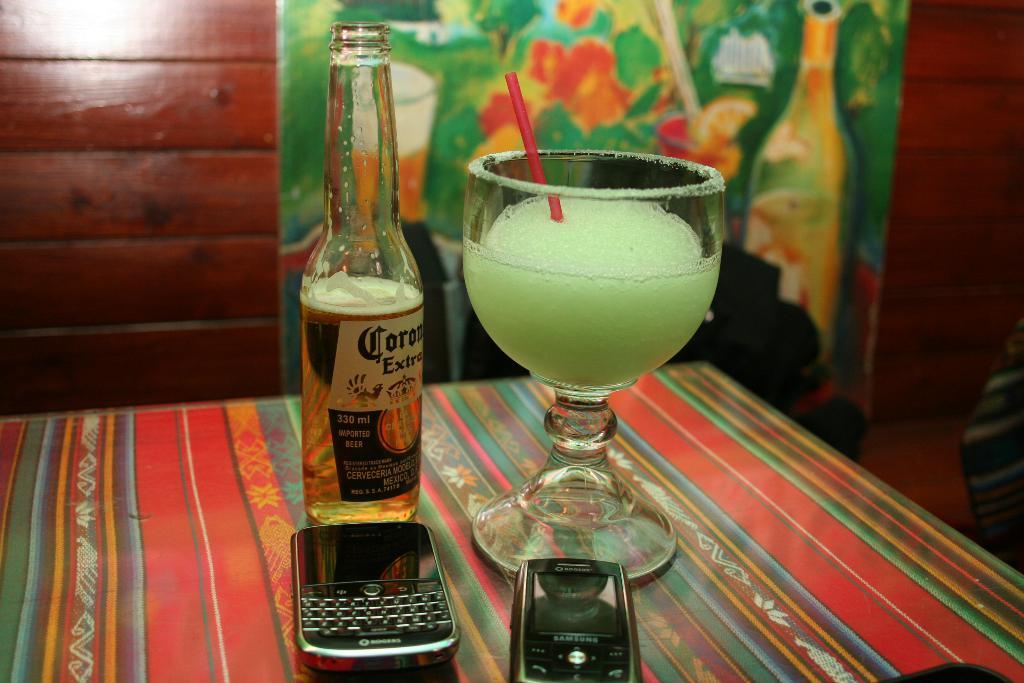What is the brand of beer?
Offer a terse response. Corona. What is the brand of alcohol?
Your answer should be compact. Corona. 